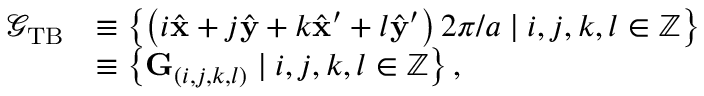Convert formula to latex. <formula><loc_0><loc_0><loc_500><loc_500>\begin{array} { r l } { \mathcal { G } _ { T B } } & { \equiv \left \{ \left ( i \hat { x } + j \hat { y } + k \hat { x } ^ { \prime } + l \hat { y } ^ { \prime } \right ) 2 \pi / a | i , j , k , l \in \mathbb { Z } \right \} } \\ & { \equiv \left \{ G _ { ( i , j , k , l ) } | i , j , k , l \in \mathbb { Z } \right \} , } \end{array}</formula> 